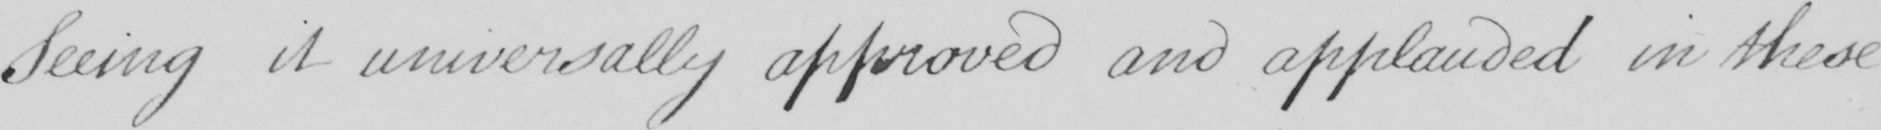Please transcribe the handwritten text in this image. Seeing it universally approved and applauded in these 